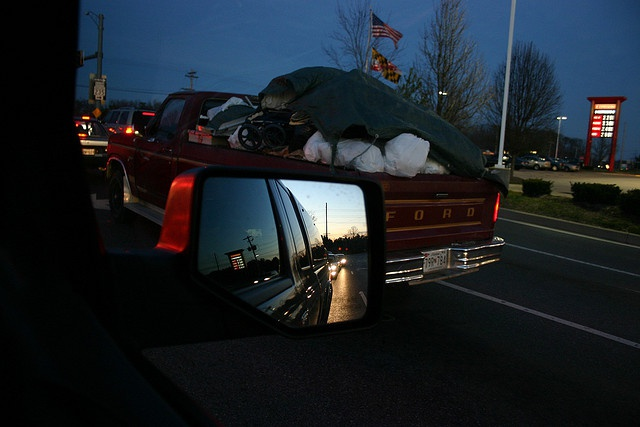Describe the objects in this image and their specific colors. I can see truck in black, gray, and maroon tones, car in black, blue, darkblue, and gray tones, car in black, maroon, tan, and gray tones, car in black, maroon, red, and brown tones, and car in black and gray tones in this image. 